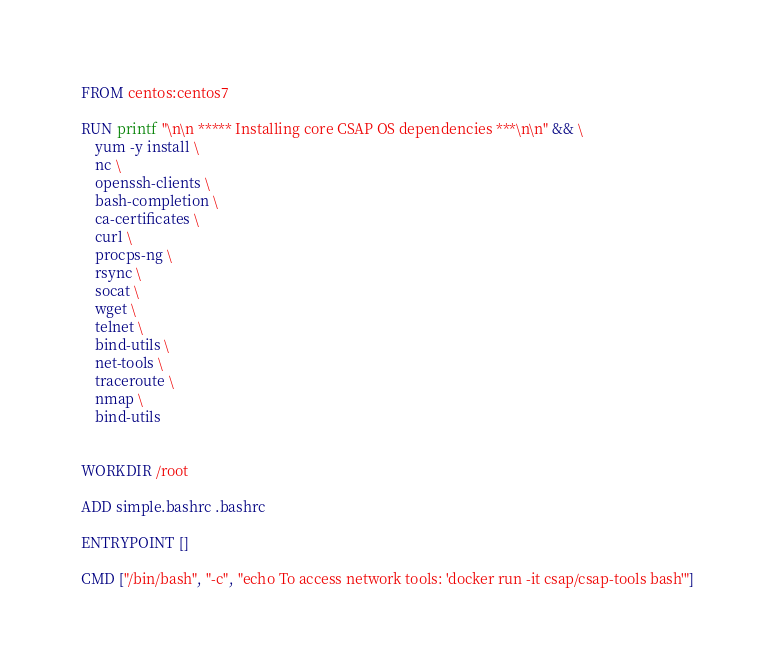Convert code to text. <code><loc_0><loc_0><loc_500><loc_500><_Dockerfile_>FROM centos:centos7

RUN printf "\n\n ***** Installing core CSAP OS dependencies ***\n\n" && \
	yum -y install \
	nc \
	openssh-clients \
	bash-completion \
	ca-certificates \
	curl \
	procps-ng \
	rsync \
	socat \
	wget \
	telnet \
	bind-utils \
	net-tools \
	traceroute \
	nmap \
	bind-utils


WORKDIR /root

ADD simple.bashrc .bashrc

ENTRYPOINT []

CMD ["/bin/bash", "-c", "echo To access network tools: 'docker run -it csap/csap-tools bash'"]</code> 